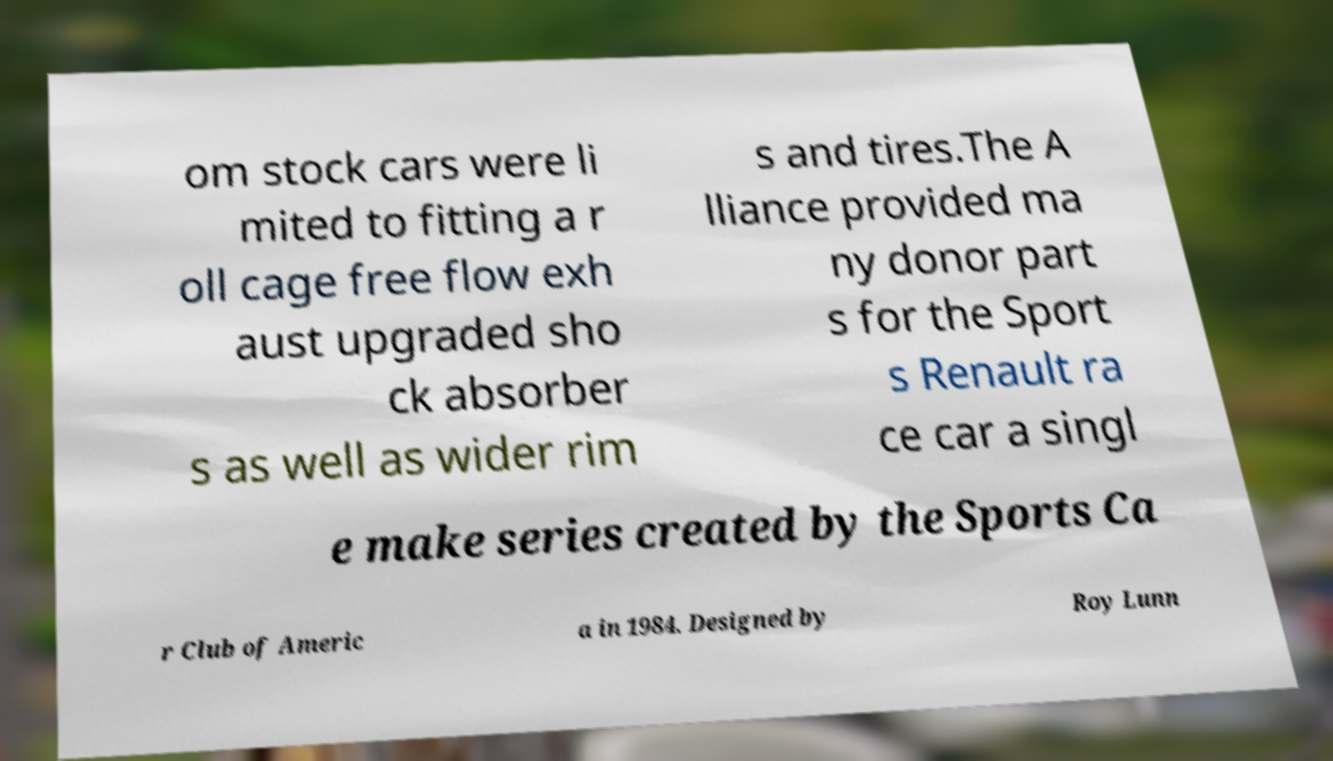There's text embedded in this image that I need extracted. Can you transcribe it verbatim? om stock cars were li mited to fitting a r oll cage free flow exh aust upgraded sho ck absorber s as well as wider rim s and tires.The A lliance provided ma ny donor part s for the Sport s Renault ra ce car a singl e make series created by the Sports Ca r Club of Americ a in 1984. Designed by Roy Lunn 